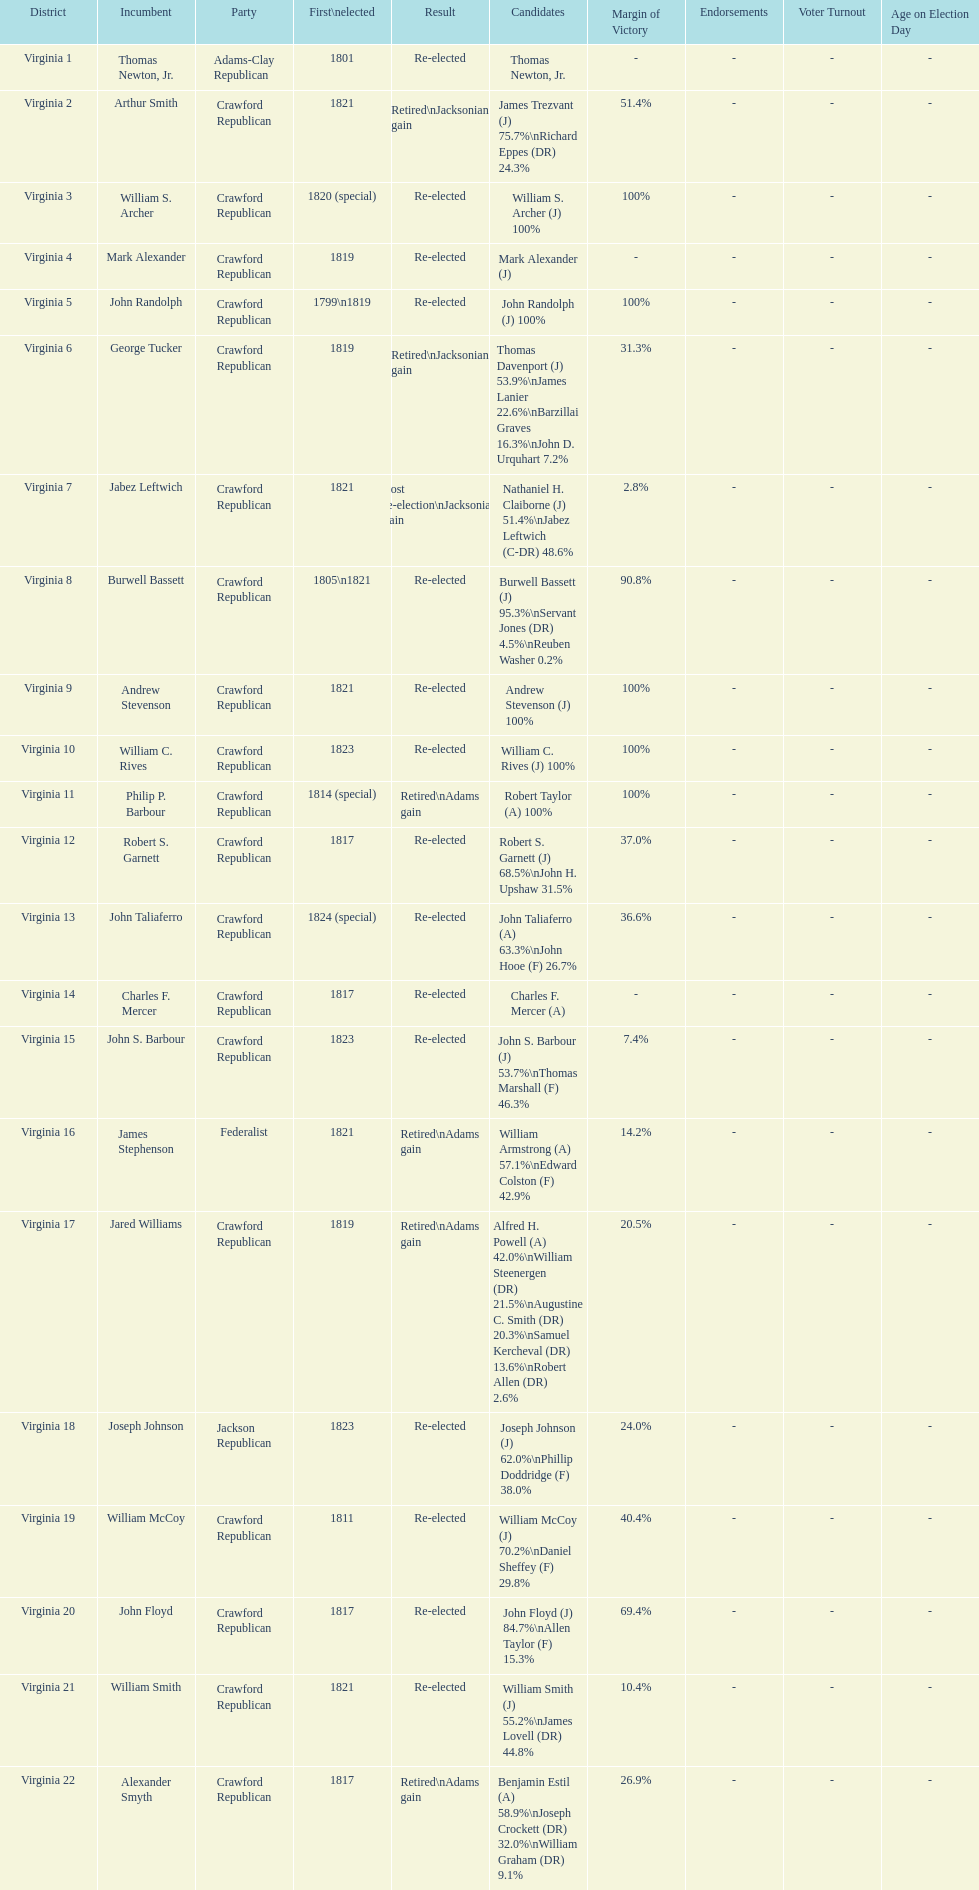What party is a crawford republican? Crawford Republican, Crawford Republican, Crawford Republican, Crawford Republican, Crawford Republican, Crawford Republican, Crawford Republican, Crawford Republican, Crawford Republican, Crawford Republican, Crawford Republican, Crawford Republican, Crawford Republican, Crawford Republican, Crawford Republican, Crawford Republican, Crawford Republican, Crawford Republican, Crawford Republican. What candidates have over 76%? James Trezvant (J) 75.7%\nRichard Eppes (DR) 24.3%, William S. Archer (J) 100%, John Randolph (J) 100%, Burwell Bassett (J) 95.3%\nServant Jones (DR) 4.5%\nReuben Washer 0.2%, Andrew Stevenson (J) 100%, William C. Rives (J) 100%, Robert Taylor (A) 100%, John Floyd (J) 84.7%\nAllen Taylor (F) 15.3%. Which result was retired jacksonian gain? Retired\nJacksonian gain. Who was the incumbent? Arthur Smith. 